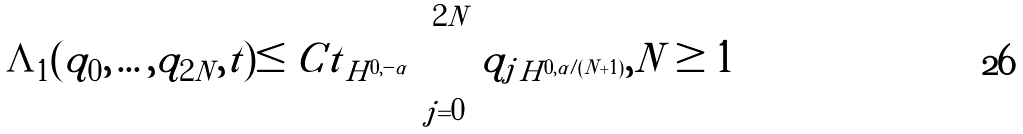Convert formula to latex. <formula><loc_0><loc_0><loc_500><loc_500>\Lambda _ { 1 } ( q _ { 0 } , \dots , q _ { 2 N } , t ) \leq C \| t \| _ { H ^ { 0 , - \alpha } } \prod _ { j = 0 } ^ { 2 N } \| q _ { j } \| _ { H ^ { 0 , \alpha / ( N + 1 ) } } , N \geq 1</formula> 